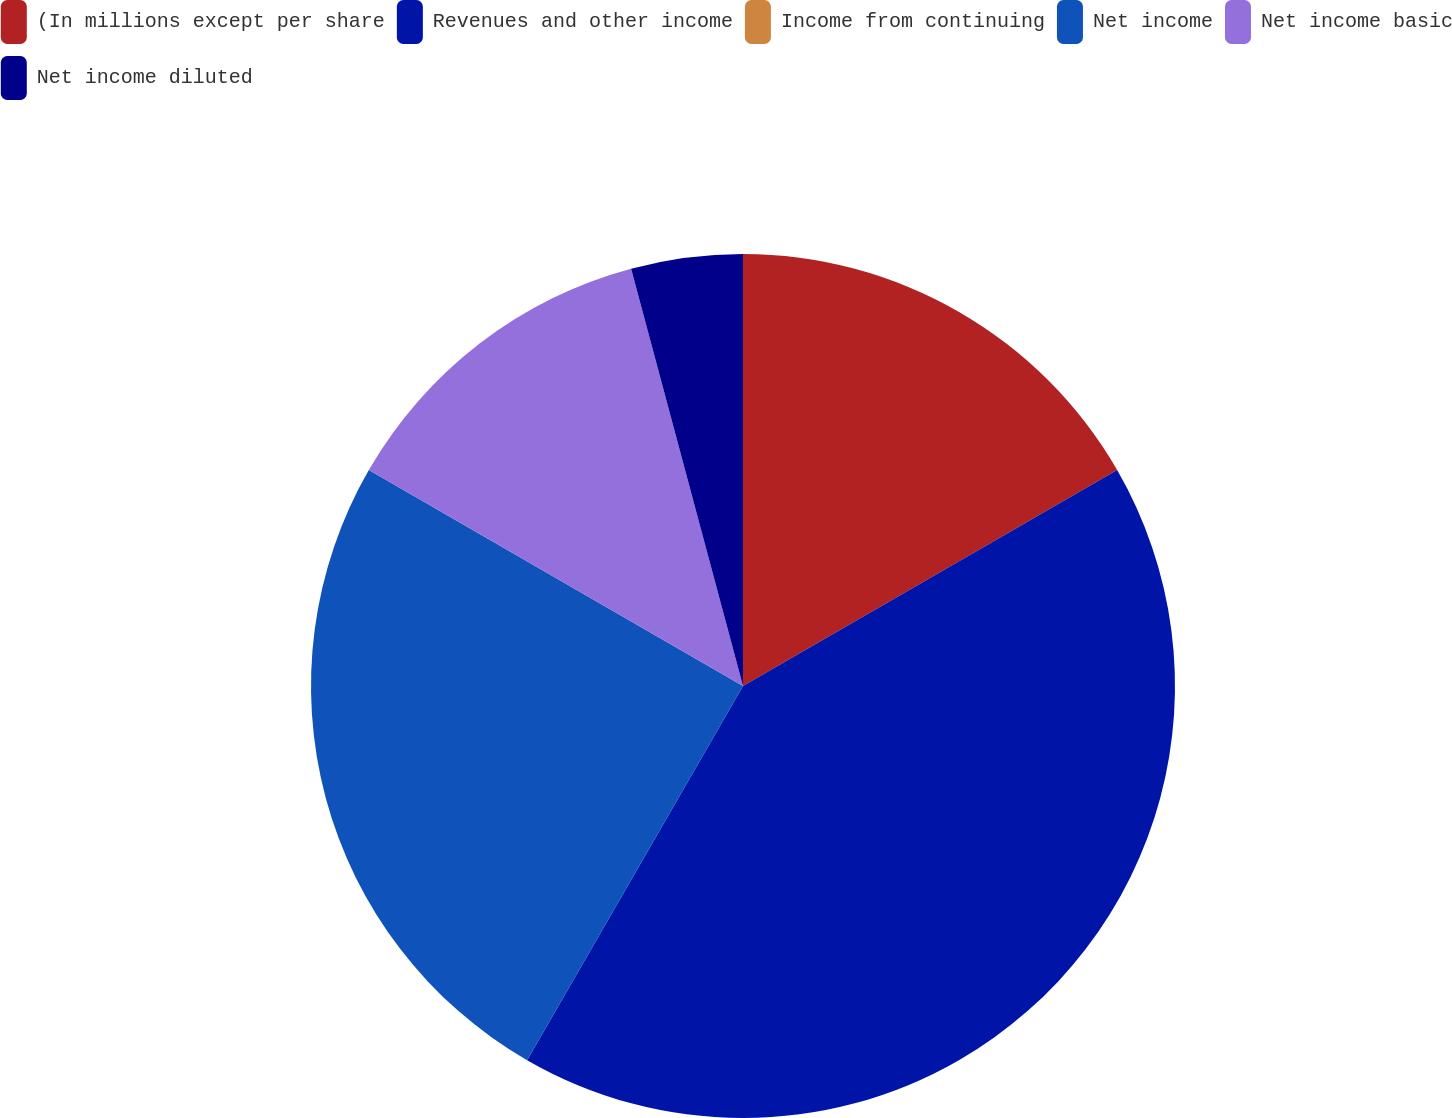<chart> <loc_0><loc_0><loc_500><loc_500><pie_chart><fcel>(In millions except per share<fcel>Revenues and other income<fcel>Income from continuing<fcel>Net income<fcel>Net income basic<fcel>Net income diluted<nl><fcel>16.67%<fcel>41.66%<fcel>0.0%<fcel>25.0%<fcel>12.5%<fcel>4.17%<nl></chart> 